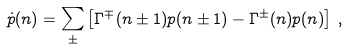Convert formula to latex. <formula><loc_0><loc_0><loc_500><loc_500>\dot { p } ( n ) = \sum _ { \pm } \left [ \Gamma ^ { \mp } ( n \pm 1 ) p ( n \pm 1 ) - \Gamma ^ { \pm } ( n ) p ( n ) \right ] \, ,</formula> 